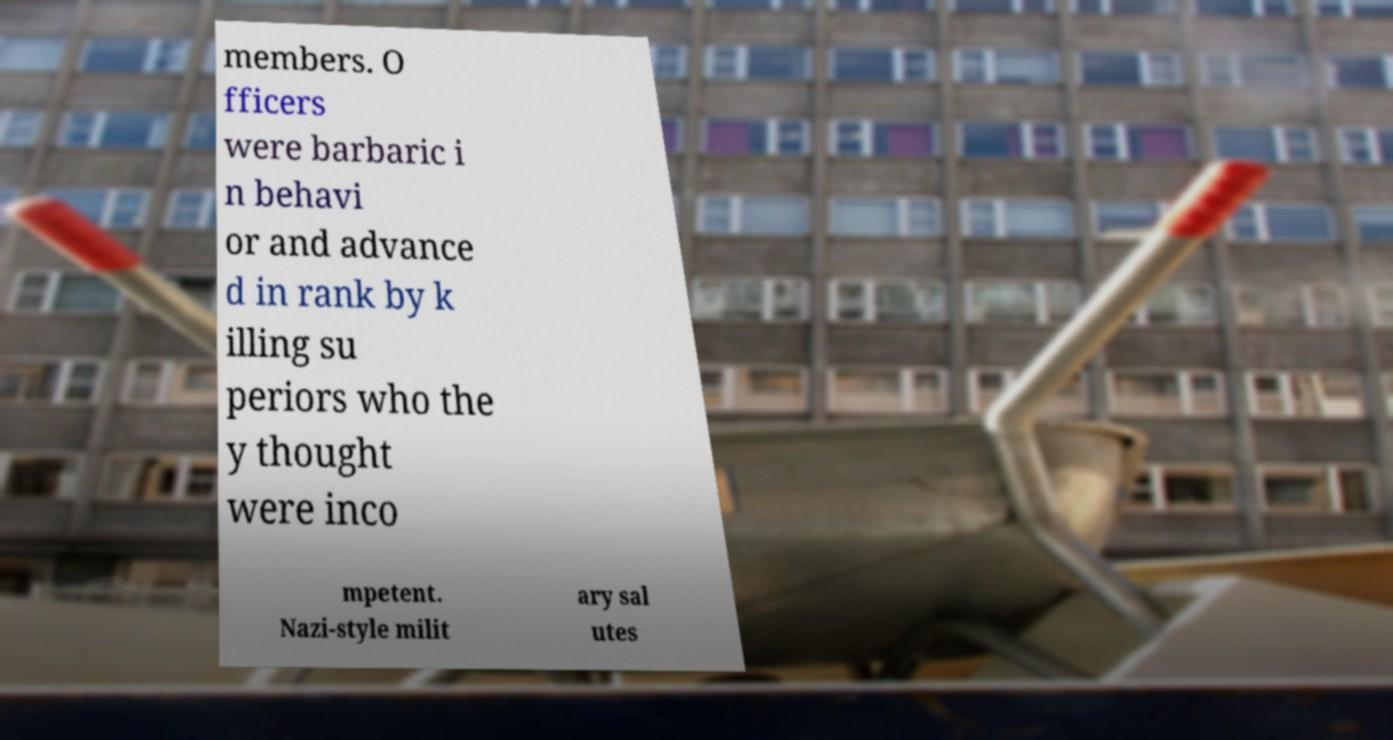Please read and relay the text visible in this image. What does it say? members. O fficers were barbaric i n behavi or and advance d in rank by k illing su periors who the y thought were inco mpetent. Nazi-style milit ary sal utes 